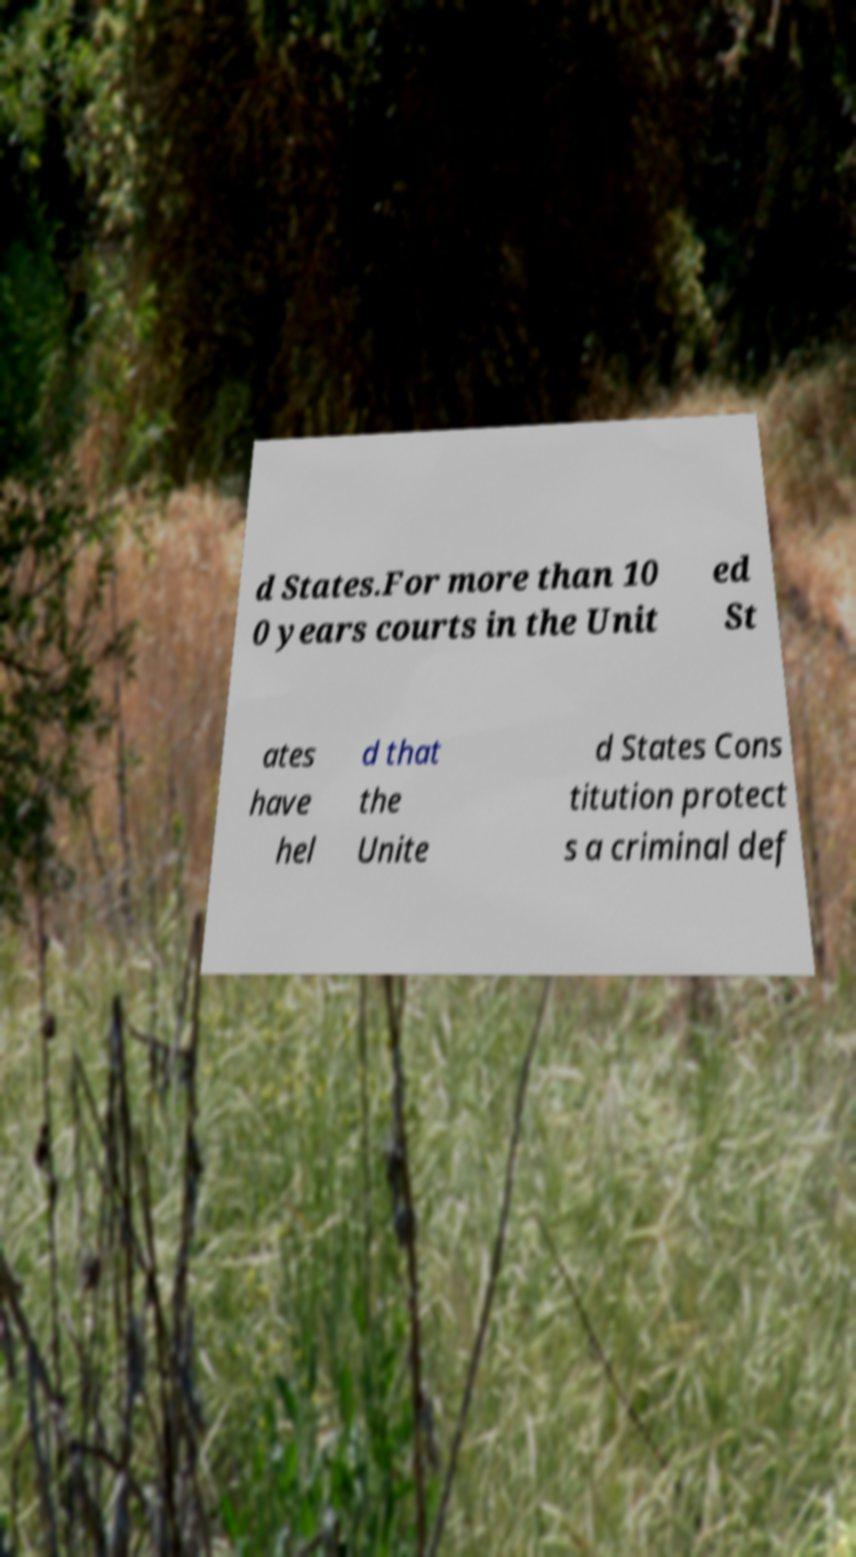I need the written content from this picture converted into text. Can you do that? d States.For more than 10 0 years courts in the Unit ed St ates have hel d that the Unite d States Cons titution protect s a criminal def 